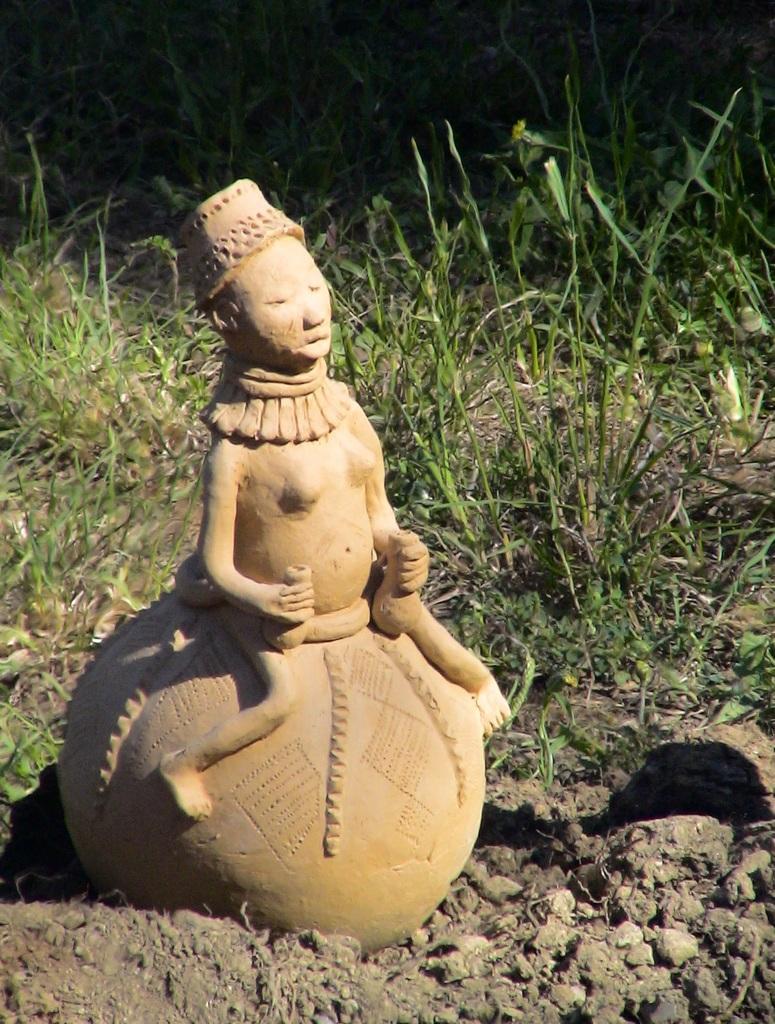Could you give a brief overview of what you see in this image? In this picture we can see a statue on the ground and in the background we can see the grass. 